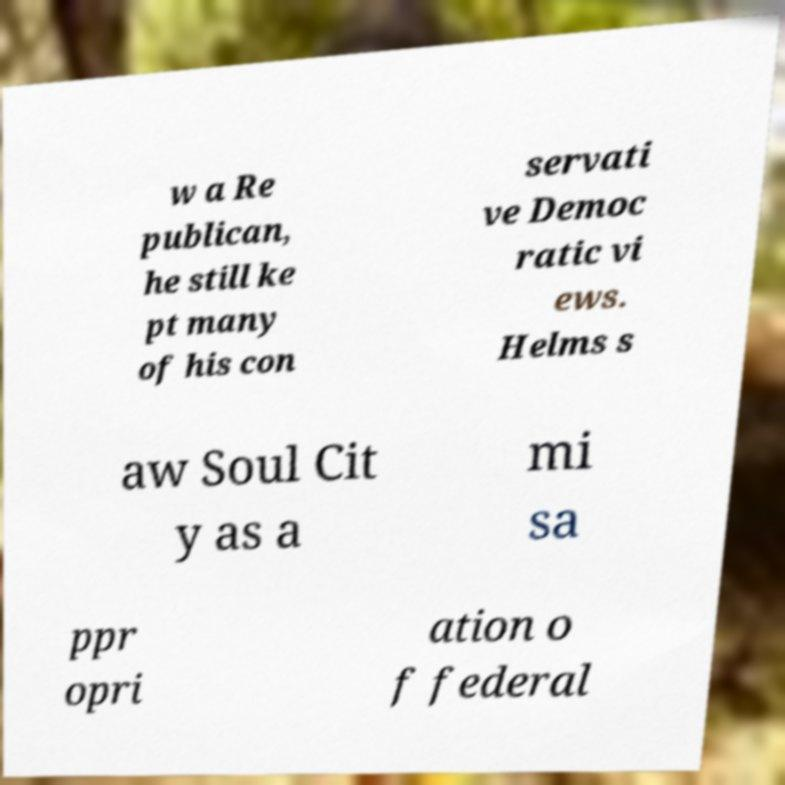Can you read and provide the text displayed in the image?This photo seems to have some interesting text. Can you extract and type it out for me? w a Re publican, he still ke pt many of his con servati ve Democ ratic vi ews. Helms s aw Soul Cit y as a mi sa ppr opri ation o f federal 